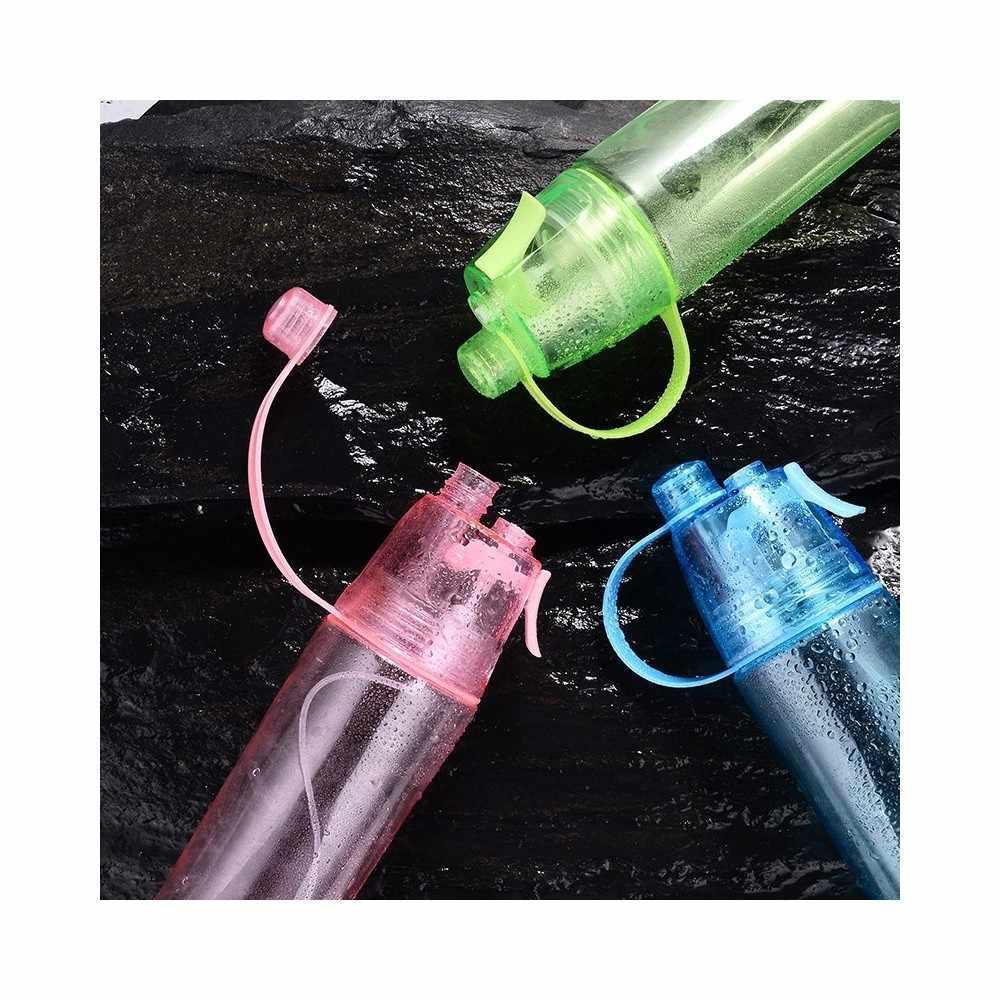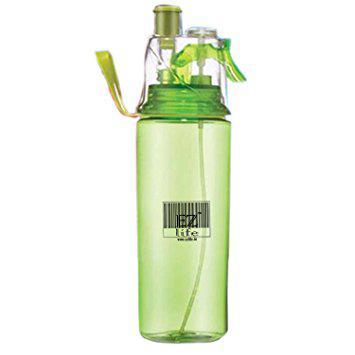The first image is the image on the left, the second image is the image on the right. Evaluate the accuracy of this statement regarding the images: "The left and right image contains four water bottle misters with at two green bottles.". Is it true? Answer yes or no. Yes. The first image is the image on the left, the second image is the image on the right. Considering the images on both sides, is "The left image has three water bottles" valid? Answer yes or no. Yes. 